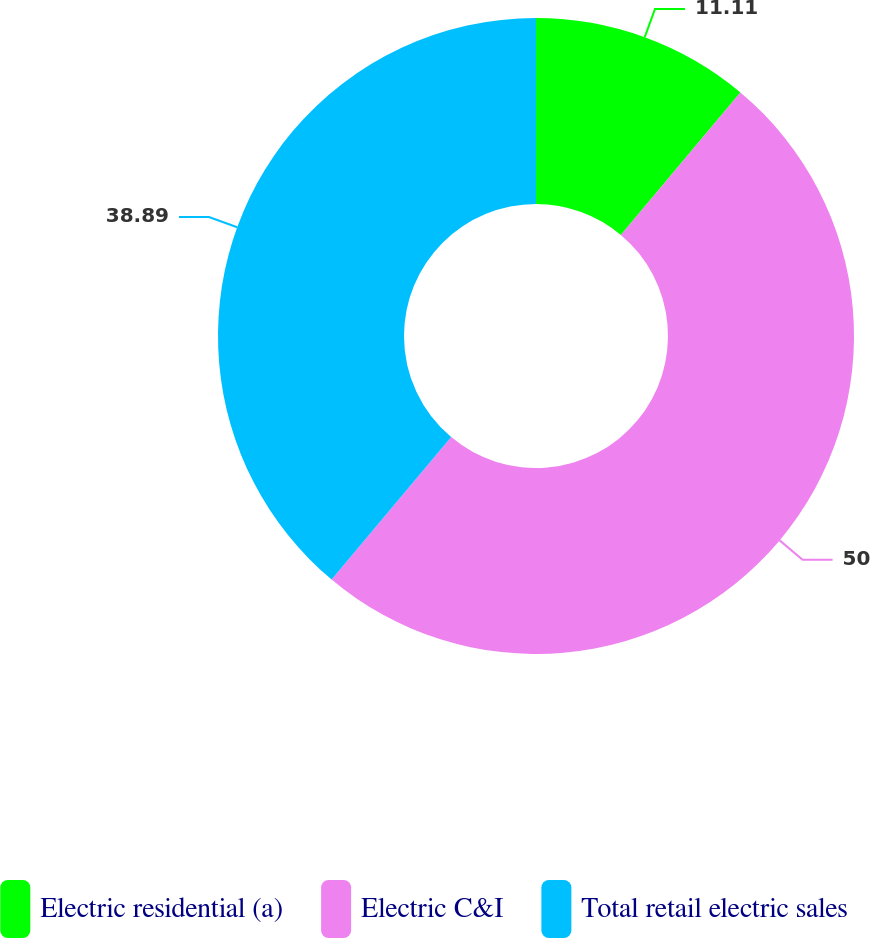Convert chart. <chart><loc_0><loc_0><loc_500><loc_500><pie_chart><fcel>Electric residential (a)<fcel>Electric C&I<fcel>Total retail electric sales<nl><fcel>11.11%<fcel>50.0%<fcel>38.89%<nl></chart> 